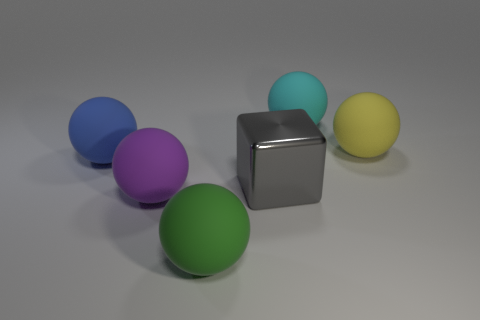What color is the matte thing right of the matte sphere behind the big rubber sphere to the right of the big cyan object? The matte object located to the right of the matte sphere and behind the large rubber sphere, which is itself to the right of the prominent cyan object, is colored yellow. This positions it in the back-center part of the image in relation to the cyan object. 